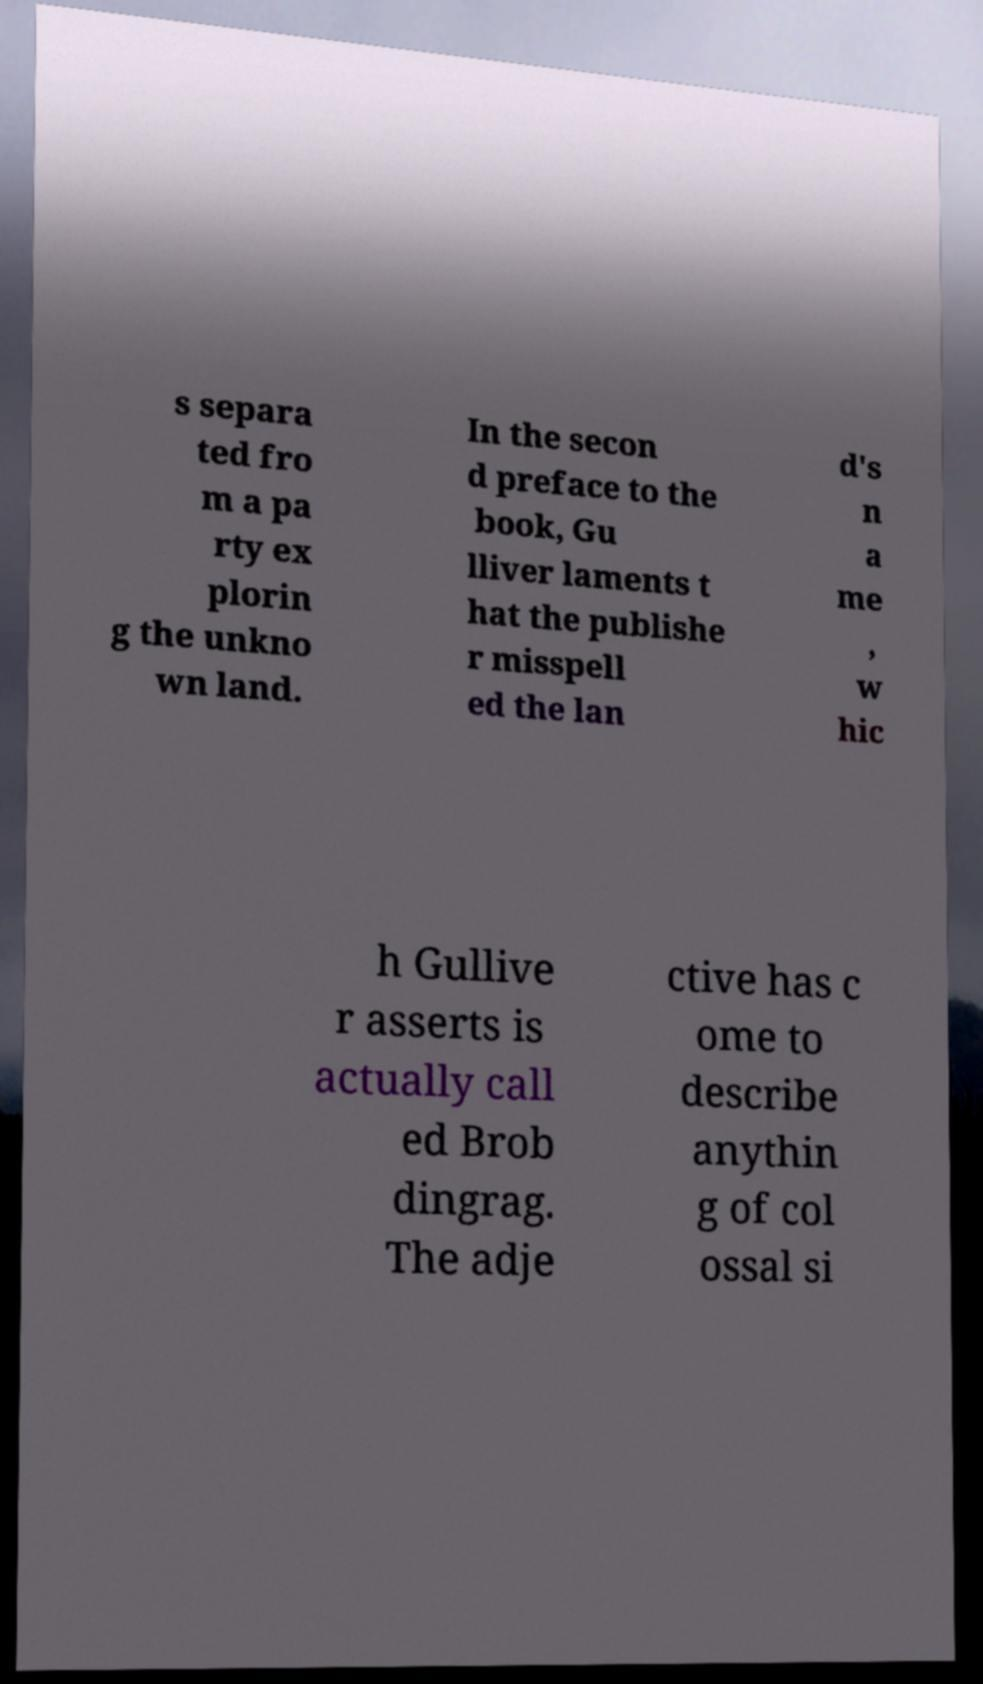Can you read and provide the text displayed in the image?This photo seems to have some interesting text. Can you extract and type it out for me? s separa ted fro m a pa rty ex plorin g the unkno wn land. In the secon d preface to the book, Gu lliver laments t hat the publishe r misspell ed the lan d's n a me , w hic h Gullive r asserts is actually call ed Brob dingrag. The adje ctive has c ome to describe anythin g of col ossal si 